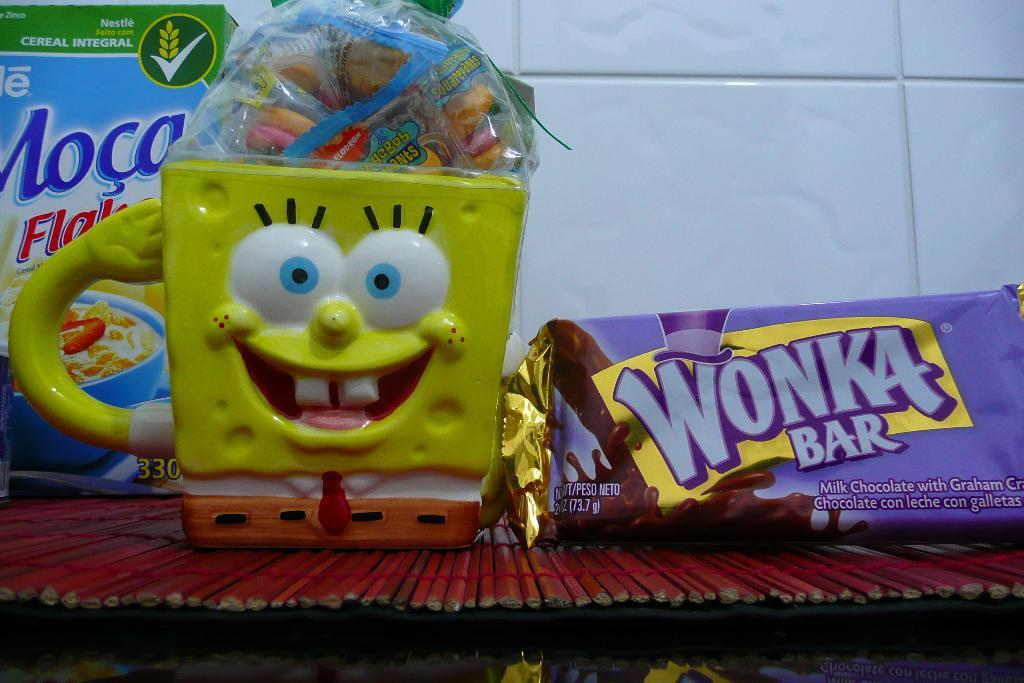What is one of the objects visible in the image? There is a cup in the image. What type of food or treat can be seen in the image? There are candies in the image. What is the shape or form of another object in the image? There is a box in the image. Can you describe an unidentified object in the image? There is an unspecified object in the image. What can be seen in the background of the image? There is a tiled wall in the background of the image. What is located at the bottom of the image? There is an object at the bottom of the image. What type of icicle can be seen hanging from the tiled wall in the image? There is no icicle present in the image; it is a tiled wall in an indoor setting. What kind of toys are visible in the image? There are no toys visible in the image. 